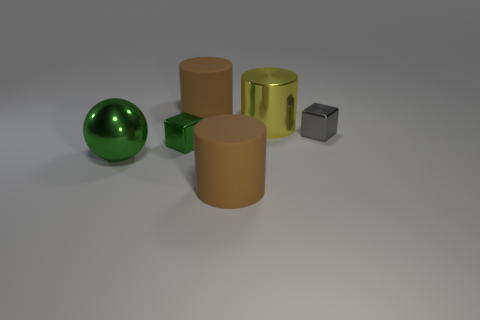There is a matte cylinder in front of the cube that is in front of the small gray object; what is its color?
Your answer should be compact. Brown. Do the big shiny thing right of the small green shiny object and the big metallic sphere have the same color?
Offer a terse response. No. Is the size of the gray block the same as the yellow cylinder?
Provide a succinct answer. No. There is a yellow metal thing that is the same size as the green metal sphere; what shape is it?
Provide a short and direct response. Cylinder. Is the size of the metallic block that is right of the yellow metal thing the same as the yellow metallic thing?
Keep it short and to the point. No. There is a sphere that is the same size as the metal cylinder; what material is it?
Offer a terse response. Metal. There is a large metallic thing that is on the right side of the cylinder that is in front of the small gray cube; are there any small gray things that are on the left side of it?
Give a very brief answer. No. Is there any other thing that has the same shape as the big green metal object?
Ensure brevity in your answer.  No. Is the color of the big matte cylinder that is in front of the yellow thing the same as the rubber cylinder that is behind the small green metallic object?
Offer a terse response. Yes. Are there any tiny yellow spheres?
Keep it short and to the point. No. 